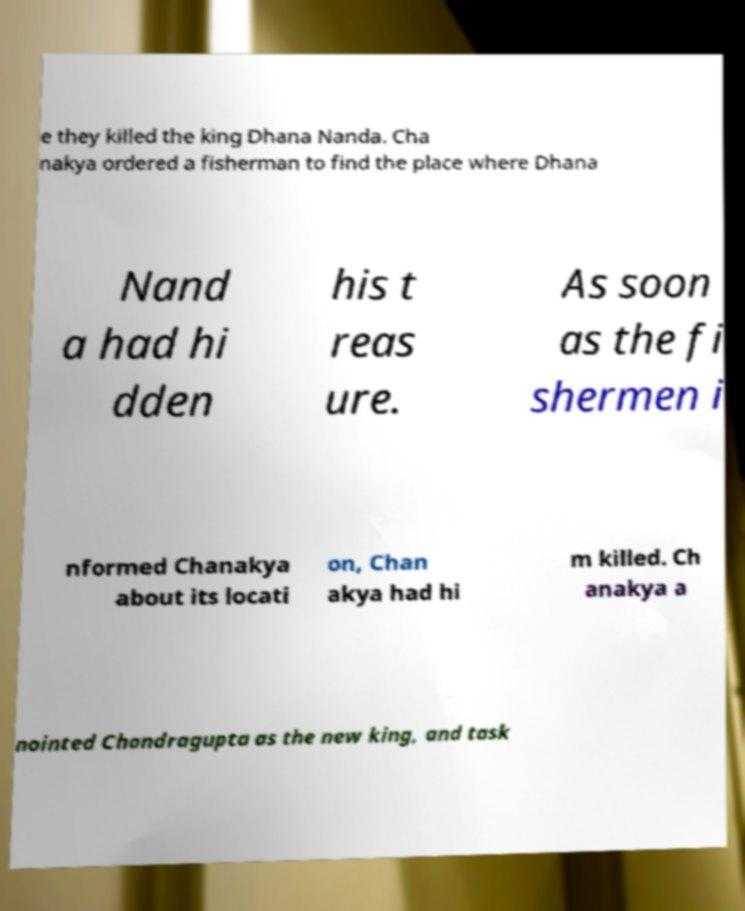Can you accurately transcribe the text from the provided image for me? e they killed the king Dhana Nanda. Cha nakya ordered a fisherman to find the place where Dhana Nand a had hi dden his t reas ure. As soon as the fi shermen i nformed Chanakya about its locati on, Chan akya had hi m killed. Ch anakya a nointed Chandragupta as the new king, and task 